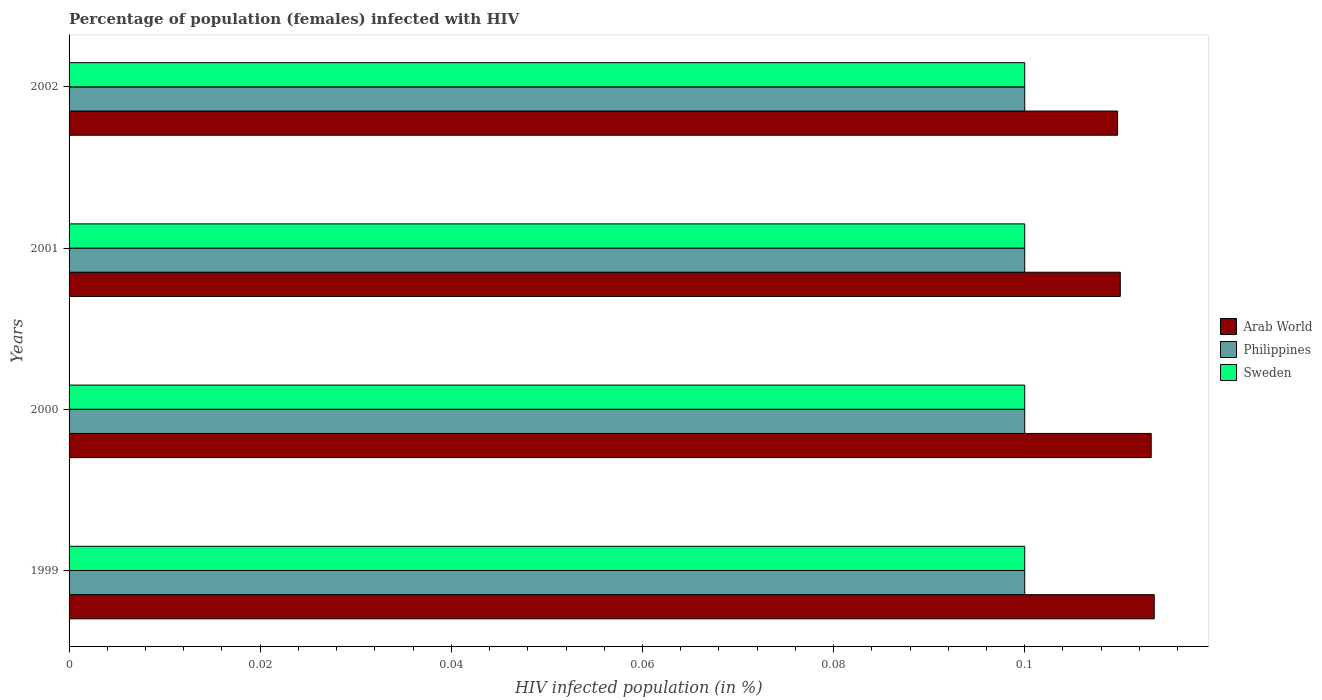How many different coloured bars are there?
Keep it short and to the point. 3. How many groups of bars are there?
Offer a terse response. 4. Are the number of bars per tick equal to the number of legend labels?
Provide a succinct answer. Yes. How many bars are there on the 4th tick from the top?
Make the answer very short. 3. Across all years, what is the maximum percentage of HIV infected female population in Philippines?
Provide a succinct answer. 0.1. Across all years, what is the minimum percentage of HIV infected female population in Arab World?
Your response must be concise. 0.11. In which year was the percentage of HIV infected female population in Arab World minimum?
Provide a short and direct response. 2002. What is the total percentage of HIV infected female population in Philippines in the graph?
Give a very brief answer. 0.4. What is the difference between the percentage of HIV infected female population in Arab World in 1999 and the percentage of HIV infected female population in Philippines in 2002?
Provide a succinct answer. 0.01. In the year 2000, what is the difference between the percentage of HIV infected female population in Arab World and percentage of HIV infected female population in Sweden?
Keep it short and to the point. 0.01. In how many years, is the percentage of HIV infected female population in Arab World greater than 0.1 %?
Offer a terse response. 4. What is the ratio of the percentage of HIV infected female population in Philippines in 2001 to that in 2002?
Your answer should be compact. 1. Is the percentage of HIV infected female population in Arab World in 2000 less than that in 2002?
Keep it short and to the point. No. Is the difference between the percentage of HIV infected female population in Arab World in 1999 and 2001 greater than the difference between the percentage of HIV infected female population in Sweden in 1999 and 2001?
Your answer should be compact. Yes. What is the difference between the highest and the second highest percentage of HIV infected female population in Sweden?
Your response must be concise. 0. What is the difference between the highest and the lowest percentage of HIV infected female population in Sweden?
Offer a terse response. 0. In how many years, is the percentage of HIV infected female population in Philippines greater than the average percentage of HIV infected female population in Philippines taken over all years?
Offer a terse response. 0. How many bars are there?
Keep it short and to the point. 12. Are all the bars in the graph horizontal?
Ensure brevity in your answer.  Yes. What is the difference between two consecutive major ticks on the X-axis?
Your response must be concise. 0.02. Does the graph contain any zero values?
Keep it short and to the point. No. Does the graph contain grids?
Ensure brevity in your answer.  No. How many legend labels are there?
Keep it short and to the point. 3. What is the title of the graph?
Offer a very short reply. Percentage of population (females) infected with HIV. What is the label or title of the X-axis?
Offer a very short reply. HIV infected population (in %). What is the label or title of the Y-axis?
Your answer should be very brief. Years. What is the HIV infected population (in %) in Arab World in 1999?
Your answer should be very brief. 0.11. What is the HIV infected population (in %) in Philippines in 1999?
Keep it short and to the point. 0.1. What is the HIV infected population (in %) of Sweden in 1999?
Your answer should be very brief. 0.1. What is the HIV infected population (in %) of Arab World in 2000?
Offer a terse response. 0.11. What is the HIV infected population (in %) in Sweden in 2000?
Your answer should be compact. 0.1. What is the HIV infected population (in %) of Arab World in 2001?
Keep it short and to the point. 0.11. What is the HIV infected population (in %) in Philippines in 2001?
Provide a short and direct response. 0.1. What is the HIV infected population (in %) of Arab World in 2002?
Keep it short and to the point. 0.11. What is the HIV infected population (in %) of Sweden in 2002?
Provide a short and direct response. 0.1. Across all years, what is the maximum HIV infected population (in %) of Arab World?
Your response must be concise. 0.11. Across all years, what is the maximum HIV infected population (in %) in Philippines?
Provide a short and direct response. 0.1. Across all years, what is the minimum HIV infected population (in %) of Arab World?
Offer a terse response. 0.11. What is the total HIV infected population (in %) in Arab World in the graph?
Offer a very short reply. 0.45. What is the total HIV infected population (in %) of Sweden in the graph?
Your response must be concise. 0.4. What is the difference between the HIV infected population (in %) in Arab World in 1999 and that in 2000?
Offer a terse response. 0. What is the difference between the HIV infected population (in %) in Philippines in 1999 and that in 2000?
Give a very brief answer. 0. What is the difference between the HIV infected population (in %) of Arab World in 1999 and that in 2001?
Give a very brief answer. 0. What is the difference between the HIV infected population (in %) of Arab World in 1999 and that in 2002?
Give a very brief answer. 0. What is the difference between the HIV infected population (in %) of Sweden in 1999 and that in 2002?
Offer a very short reply. 0. What is the difference between the HIV infected population (in %) of Arab World in 2000 and that in 2001?
Keep it short and to the point. 0. What is the difference between the HIV infected population (in %) of Sweden in 2000 and that in 2001?
Offer a terse response. 0. What is the difference between the HIV infected population (in %) in Arab World in 2000 and that in 2002?
Give a very brief answer. 0. What is the difference between the HIV infected population (in %) of Philippines in 2000 and that in 2002?
Keep it short and to the point. 0. What is the difference between the HIV infected population (in %) of Sweden in 2000 and that in 2002?
Offer a terse response. 0. What is the difference between the HIV infected population (in %) of Arab World in 2001 and that in 2002?
Offer a very short reply. 0. What is the difference between the HIV infected population (in %) in Arab World in 1999 and the HIV infected population (in %) in Philippines in 2000?
Your answer should be compact. 0.01. What is the difference between the HIV infected population (in %) of Arab World in 1999 and the HIV infected population (in %) of Sweden in 2000?
Keep it short and to the point. 0.01. What is the difference between the HIV infected population (in %) of Philippines in 1999 and the HIV infected population (in %) of Sweden in 2000?
Provide a short and direct response. 0. What is the difference between the HIV infected population (in %) of Arab World in 1999 and the HIV infected population (in %) of Philippines in 2001?
Your response must be concise. 0.01. What is the difference between the HIV infected population (in %) in Arab World in 1999 and the HIV infected population (in %) in Sweden in 2001?
Your answer should be compact. 0.01. What is the difference between the HIV infected population (in %) of Philippines in 1999 and the HIV infected population (in %) of Sweden in 2001?
Ensure brevity in your answer.  0. What is the difference between the HIV infected population (in %) in Arab World in 1999 and the HIV infected population (in %) in Philippines in 2002?
Offer a terse response. 0.01. What is the difference between the HIV infected population (in %) in Arab World in 1999 and the HIV infected population (in %) in Sweden in 2002?
Give a very brief answer. 0.01. What is the difference between the HIV infected population (in %) in Arab World in 2000 and the HIV infected population (in %) in Philippines in 2001?
Your answer should be compact. 0.01. What is the difference between the HIV infected population (in %) of Arab World in 2000 and the HIV infected population (in %) of Sweden in 2001?
Your answer should be very brief. 0.01. What is the difference between the HIV infected population (in %) of Arab World in 2000 and the HIV infected population (in %) of Philippines in 2002?
Offer a very short reply. 0.01. What is the difference between the HIV infected population (in %) in Arab World in 2000 and the HIV infected population (in %) in Sweden in 2002?
Offer a very short reply. 0.01. What is the difference between the HIV infected population (in %) in Philippines in 2000 and the HIV infected population (in %) in Sweden in 2002?
Provide a succinct answer. 0. What is the average HIV infected population (in %) in Arab World per year?
Keep it short and to the point. 0.11. In the year 1999, what is the difference between the HIV infected population (in %) in Arab World and HIV infected population (in %) in Philippines?
Offer a very short reply. 0.01. In the year 1999, what is the difference between the HIV infected population (in %) in Arab World and HIV infected population (in %) in Sweden?
Ensure brevity in your answer.  0.01. In the year 1999, what is the difference between the HIV infected population (in %) of Philippines and HIV infected population (in %) of Sweden?
Your response must be concise. 0. In the year 2000, what is the difference between the HIV infected population (in %) of Arab World and HIV infected population (in %) of Philippines?
Ensure brevity in your answer.  0.01. In the year 2000, what is the difference between the HIV infected population (in %) of Arab World and HIV infected population (in %) of Sweden?
Your answer should be very brief. 0.01. In the year 2000, what is the difference between the HIV infected population (in %) of Philippines and HIV infected population (in %) of Sweden?
Make the answer very short. 0. In the year 2001, what is the difference between the HIV infected population (in %) in Arab World and HIV infected population (in %) in Philippines?
Your response must be concise. 0.01. In the year 2001, what is the difference between the HIV infected population (in %) of Philippines and HIV infected population (in %) of Sweden?
Give a very brief answer. 0. In the year 2002, what is the difference between the HIV infected population (in %) of Arab World and HIV infected population (in %) of Philippines?
Your response must be concise. 0.01. In the year 2002, what is the difference between the HIV infected population (in %) of Arab World and HIV infected population (in %) of Sweden?
Ensure brevity in your answer.  0.01. In the year 2002, what is the difference between the HIV infected population (in %) in Philippines and HIV infected population (in %) in Sweden?
Provide a succinct answer. 0. What is the ratio of the HIV infected population (in %) in Arab World in 1999 to that in 2001?
Your response must be concise. 1.03. What is the ratio of the HIV infected population (in %) of Sweden in 1999 to that in 2001?
Keep it short and to the point. 1. What is the ratio of the HIV infected population (in %) of Arab World in 1999 to that in 2002?
Provide a short and direct response. 1.03. What is the ratio of the HIV infected population (in %) of Sweden in 1999 to that in 2002?
Your answer should be very brief. 1. What is the ratio of the HIV infected population (in %) in Arab World in 2000 to that in 2001?
Offer a very short reply. 1.03. What is the ratio of the HIV infected population (in %) of Sweden in 2000 to that in 2001?
Ensure brevity in your answer.  1. What is the ratio of the HIV infected population (in %) of Arab World in 2000 to that in 2002?
Make the answer very short. 1.03. What is the ratio of the HIV infected population (in %) in Philippines in 2000 to that in 2002?
Offer a terse response. 1. What is the ratio of the HIV infected population (in %) of Sweden in 2000 to that in 2002?
Your response must be concise. 1. What is the ratio of the HIV infected population (in %) of Philippines in 2001 to that in 2002?
Ensure brevity in your answer.  1. What is the ratio of the HIV infected population (in %) in Sweden in 2001 to that in 2002?
Your answer should be very brief. 1. What is the difference between the highest and the second highest HIV infected population (in %) of Philippines?
Provide a short and direct response. 0. What is the difference between the highest and the second highest HIV infected population (in %) in Sweden?
Offer a terse response. 0. What is the difference between the highest and the lowest HIV infected population (in %) in Arab World?
Provide a succinct answer. 0. What is the difference between the highest and the lowest HIV infected population (in %) of Philippines?
Provide a succinct answer. 0. 